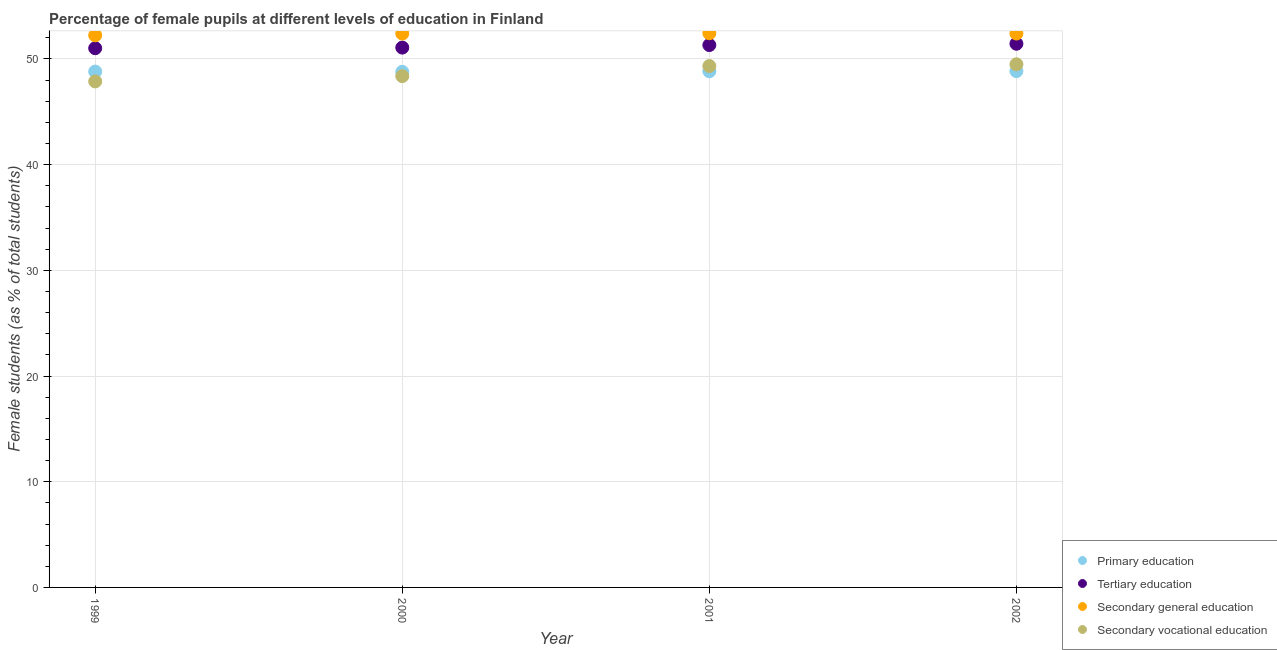What is the percentage of female students in primary education in 2001?
Offer a very short reply. 48.84. Across all years, what is the maximum percentage of female students in tertiary education?
Your answer should be compact. 51.44. Across all years, what is the minimum percentage of female students in secondary education?
Make the answer very short. 52.24. In which year was the percentage of female students in secondary education maximum?
Provide a short and direct response. 2001. In which year was the percentage of female students in secondary vocational education minimum?
Your response must be concise. 1999. What is the total percentage of female students in secondary vocational education in the graph?
Your response must be concise. 195.09. What is the difference between the percentage of female students in tertiary education in 1999 and that in 2002?
Keep it short and to the point. -0.42. What is the difference between the percentage of female students in primary education in 2002 and the percentage of female students in secondary vocational education in 2000?
Offer a terse response. 0.47. What is the average percentage of female students in tertiary education per year?
Ensure brevity in your answer.  51.21. In the year 2001, what is the difference between the percentage of female students in secondary education and percentage of female students in secondary vocational education?
Offer a terse response. 3.1. What is the ratio of the percentage of female students in secondary vocational education in 1999 to that in 2001?
Give a very brief answer. 0.97. Is the percentage of female students in secondary education in 1999 less than that in 2001?
Offer a very short reply. Yes. Is the difference between the percentage of female students in primary education in 1999 and 2000 greater than the difference between the percentage of female students in secondary vocational education in 1999 and 2000?
Keep it short and to the point. Yes. What is the difference between the highest and the second highest percentage of female students in secondary vocational education?
Keep it short and to the point. 0.17. What is the difference between the highest and the lowest percentage of female students in tertiary education?
Give a very brief answer. 0.42. In how many years, is the percentage of female students in primary education greater than the average percentage of female students in primary education taken over all years?
Give a very brief answer. 2. Is the percentage of female students in tertiary education strictly less than the percentage of female students in primary education over the years?
Make the answer very short. No. How many dotlines are there?
Ensure brevity in your answer.  4. How many years are there in the graph?
Your answer should be very brief. 4. What is the difference between two consecutive major ticks on the Y-axis?
Your answer should be compact. 10. Does the graph contain any zero values?
Give a very brief answer. No. Where does the legend appear in the graph?
Offer a very short reply. Bottom right. How many legend labels are there?
Offer a terse response. 4. What is the title of the graph?
Make the answer very short. Percentage of female pupils at different levels of education in Finland. Does "Taxes on exports" appear as one of the legend labels in the graph?
Offer a terse response. No. What is the label or title of the X-axis?
Your answer should be compact. Year. What is the label or title of the Y-axis?
Your response must be concise. Female students (as % of total students). What is the Female students (as % of total students) in Primary education in 1999?
Ensure brevity in your answer.  48.81. What is the Female students (as % of total students) of Tertiary education in 1999?
Your answer should be compact. 51.02. What is the Female students (as % of total students) in Secondary general education in 1999?
Your answer should be compact. 52.24. What is the Female students (as % of total students) in Secondary vocational education in 1999?
Your answer should be compact. 47.88. What is the Female students (as % of total students) in Primary education in 2000?
Your response must be concise. 48.78. What is the Female students (as % of total students) in Tertiary education in 2000?
Make the answer very short. 51.08. What is the Female students (as % of total students) in Secondary general education in 2000?
Your response must be concise. 52.41. What is the Female students (as % of total students) in Secondary vocational education in 2000?
Your answer should be very brief. 48.38. What is the Female students (as % of total students) of Primary education in 2001?
Your answer should be very brief. 48.84. What is the Female students (as % of total students) of Tertiary education in 2001?
Your response must be concise. 51.32. What is the Female students (as % of total students) of Secondary general education in 2001?
Your response must be concise. 52.44. What is the Female students (as % of total students) in Secondary vocational education in 2001?
Your response must be concise. 49.33. What is the Female students (as % of total students) in Primary education in 2002?
Ensure brevity in your answer.  48.85. What is the Female students (as % of total students) of Tertiary education in 2002?
Offer a very short reply. 51.44. What is the Female students (as % of total students) of Secondary general education in 2002?
Provide a short and direct response. 52.41. What is the Female students (as % of total students) of Secondary vocational education in 2002?
Make the answer very short. 49.5. Across all years, what is the maximum Female students (as % of total students) of Primary education?
Make the answer very short. 48.85. Across all years, what is the maximum Female students (as % of total students) of Tertiary education?
Your answer should be compact. 51.44. Across all years, what is the maximum Female students (as % of total students) in Secondary general education?
Provide a short and direct response. 52.44. Across all years, what is the maximum Female students (as % of total students) of Secondary vocational education?
Keep it short and to the point. 49.5. Across all years, what is the minimum Female students (as % of total students) in Primary education?
Ensure brevity in your answer.  48.78. Across all years, what is the minimum Female students (as % of total students) in Tertiary education?
Your answer should be very brief. 51.02. Across all years, what is the minimum Female students (as % of total students) in Secondary general education?
Provide a short and direct response. 52.24. Across all years, what is the minimum Female students (as % of total students) of Secondary vocational education?
Offer a very short reply. 47.88. What is the total Female students (as % of total students) of Primary education in the graph?
Offer a terse response. 195.28. What is the total Female students (as % of total students) of Tertiary education in the graph?
Offer a terse response. 204.85. What is the total Female students (as % of total students) of Secondary general education in the graph?
Make the answer very short. 209.49. What is the total Female students (as % of total students) in Secondary vocational education in the graph?
Provide a short and direct response. 195.09. What is the difference between the Female students (as % of total students) of Primary education in 1999 and that in 2000?
Make the answer very short. 0.03. What is the difference between the Female students (as % of total students) in Tertiary education in 1999 and that in 2000?
Offer a terse response. -0.06. What is the difference between the Female students (as % of total students) in Secondary general education in 1999 and that in 2000?
Provide a short and direct response. -0.17. What is the difference between the Female students (as % of total students) in Secondary vocational education in 1999 and that in 2000?
Provide a succinct answer. -0.5. What is the difference between the Female students (as % of total students) of Primary education in 1999 and that in 2001?
Provide a succinct answer. -0.04. What is the difference between the Female students (as % of total students) of Tertiary education in 1999 and that in 2001?
Your response must be concise. -0.3. What is the difference between the Female students (as % of total students) of Secondary general education in 1999 and that in 2001?
Your response must be concise. -0.2. What is the difference between the Female students (as % of total students) of Secondary vocational education in 1999 and that in 2001?
Provide a short and direct response. -1.46. What is the difference between the Female students (as % of total students) of Primary education in 1999 and that in 2002?
Offer a terse response. -0.04. What is the difference between the Female students (as % of total students) of Tertiary education in 1999 and that in 2002?
Your answer should be very brief. -0.42. What is the difference between the Female students (as % of total students) in Secondary general education in 1999 and that in 2002?
Your response must be concise. -0.17. What is the difference between the Female students (as % of total students) in Secondary vocational education in 1999 and that in 2002?
Your answer should be very brief. -1.62. What is the difference between the Female students (as % of total students) in Primary education in 2000 and that in 2001?
Your answer should be compact. -0.06. What is the difference between the Female students (as % of total students) in Tertiary education in 2000 and that in 2001?
Ensure brevity in your answer.  -0.24. What is the difference between the Female students (as % of total students) in Secondary general education in 2000 and that in 2001?
Your answer should be compact. -0.03. What is the difference between the Female students (as % of total students) in Secondary vocational education in 2000 and that in 2001?
Your response must be concise. -0.95. What is the difference between the Female students (as % of total students) of Primary education in 2000 and that in 2002?
Provide a succinct answer. -0.07. What is the difference between the Female students (as % of total students) in Tertiary education in 2000 and that in 2002?
Keep it short and to the point. -0.37. What is the difference between the Female students (as % of total students) in Secondary general education in 2000 and that in 2002?
Give a very brief answer. 0. What is the difference between the Female students (as % of total students) in Secondary vocational education in 2000 and that in 2002?
Your answer should be compact. -1.12. What is the difference between the Female students (as % of total students) in Primary education in 2001 and that in 2002?
Provide a succinct answer. -0.01. What is the difference between the Female students (as % of total students) in Tertiary education in 2001 and that in 2002?
Ensure brevity in your answer.  -0.13. What is the difference between the Female students (as % of total students) of Secondary general education in 2001 and that in 2002?
Your answer should be very brief. 0.03. What is the difference between the Female students (as % of total students) in Secondary vocational education in 2001 and that in 2002?
Your answer should be compact. -0.17. What is the difference between the Female students (as % of total students) of Primary education in 1999 and the Female students (as % of total students) of Tertiary education in 2000?
Provide a short and direct response. -2.27. What is the difference between the Female students (as % of total students) in Primary education in 1999 and the Female students (as % of total students) in Secondary general education in 2000?
Your answer should be very brief. -3.6. What is the difference between the Female students (as % of total students) in Primary education in 1999 and the Female students (as % of total students) in Secondary vocational education in 2000?
Provide a succinct answer. 0.43. What is the difference between the Female students (as % of total students) in Tertiary education in 1999 and the Female students (as % of total students) in Secondary general education in 2000?
Offer a very short reply. -1.39. What is the difference between the Female students (as % of total students) in Tertiary education in 1999 and the Female students (as % of total students) in Secondary vocational education in 2000?
Provide a succinct answer. 2.64. What is the difference between the Female students (as % of total students) of Secondary general education in 1999 and the Female students (as % of total students) of Secondary vocational education in 2000?
Keep it short and to the point. 3.86. What is the difference between the Female students (as % of total students) in Primary education in 1999 and the Female students (as % of total students) in Tertiary education in 2001?
Your response must be concise. -2.51. What is the difference between the Female students (as % of total students) in Primary education in 1999 and the Female students (as % of total students) in Secondary general education in 2001?
Provide a short and direct response. -3.63. What is the difference between the Female students (as % of total students) in Primary education in 1999 and the Female students (as % of total students) in Secondary vocational education in 2001?
Offer a terse response. -0.53. What is the difference between the Female students (as % of total students) of Tertiary education in 1999 and the Female students (as % of total students) of Secondary general education in 2001?
Your response must be concise. -1.42. What is the difference between the Female students (as % of total students) in Tertiary education in 1999 and the Female students (as % of total students) in Secondary vocational education in 2001?
Your answer should be very brief. 1.69. What is the difference between the Female students (as % of total students) in Secondary general education in 1999 and the Female students (as % of total students) in Secondary vocational education in 2001?
Your response must be concise. 2.91. What is the difference between the Female students (as % of total students) in Primary education in 1999 and the Female students (as % of total students) in Tertiary education in 2002?
Make the answer very short. -2.64. What is the difference between the Female students (as % of total students) in Primary education in 1999 and the Female students (as % of total students) in Secondary general education in 2002?
Your answer should be very brief. -3.6. What is the difference between the Female students (as % of total students) in Primary education in 1999 and the Female students (as % of total students) in Secondary vocational education in 2002?
Your answer should be compact. -0.69. What is the difference between the Female students (as % of total students) of Tertiary education in 1999 and the Female students (as % of total students) of Secondary general education in 2002?
Your response must be concise. -1.39. What is the difference between the Female students (as % of total students) in Tertiary education in 1999 and the Female students (as % of total students) in Secondary vocational education in 2002?
Offer a very short reply. 1.52. What is the difference between the Female students (as % of total students) in Secondary general education in 1999 and the Female students (as % of total students) in Secondary vocational education in 2002?
Offer a terse response. 2.74. What is the difference between the Female students (as % of total students) of Primary education in 2000 and the Female students (as % of total students) of Tertiary education in 2001?
Keep it short and to the point. -2.53. What is the difference between the Female students (as % of total students) in Primary education in 2000 and the Female students (as % of total students) in Secondary general education in 2001?
Your response must be concise. -3.65. What is the difference between the Female students (as % of total students) in Primary education in 2000 and the Female students (as % of total students) in Secondary vocational education in 2001?
Provide a succinct answer. -0.55. What is the difference between the Female students (as % of total students) in Tertiary education in 2000 and the Female students (as % of total students) in Secondary general education in 2001?
Your answer should be compact. -1.36. What is the difference between the Female students (as % of total students) of Tertiary education in 2000 and the Female students (as % of total students) of Secondary vocational education in 2001?
Keep it short and to the point. 1.74. What is the difference between the Female students (as % of total students) in Secondary general education in 2000 and the Female students (as % of total students) in Secondary vocational education in 2001?
Your answer should be compact. 3.07. What is the difference between the Female students (as % of total students) in Primary education in 2000 and the Female students (as % of total students) in Tertiary education in 2002?
Keep it short and to the point. -2.66. What is the difference between the Female students (as % of total students) in Primary education in 2000 and the Female students (as % of total students) in Secondary general education in 2002?
Your answer should be very brief. -3.62. What is the difference between the Female students (as % of total students) in Primary education in 2000 and the Female students (as % of total students) in Secondary vocational education in 2002?
Provide a succinct answer. -0.72. What is the difference between the Female students (as % of total students) in Tertiary education in 2000 and the Female students (as % of total students) in Secondary general education in 2002?
Your answer should be very brief. -1.33. What is the difference between the Female students (as % of total students) of Tertiary education in 2000 and the Female students (as % of total students) of Secondary vocational education in 2002?
Your answer should be compact. 1.58. What is the difference between the Female students (as % of total students) of Secondary general education in 2000 and the Female students (as % of total students) of Secondary vocational education in 2002?
Offer a very short reply. 2.91. What is the difference between the Female students (as % of total students) of Primary education in 2001 and the Female students (as % of total students) of Tertiary education in 2002?
Your answer should be very brief. -2.6. What is the difference between the Female students (as % of total students) of Primary education in 2001 and the Female students (as % of total students) of Secondary general education in 2002?
Make the answer very short. -3.56. What is the difference between the Female students (as % of total students) in Primary education in 2001 and the Female students (as % of total students) in Secondary vocational education in 2002?
Give a very brief answer. -0.65. What is the difference between the Female students (as % of total students) in Tertiary education in 2001 and the Female students (as % of total students) in Secondary general education in 2002?
Offer a very short reply. -1.09. What is the difference between the Female students (as % of total students) of Tertiary education in 2001 and the Female students (as % of total students) of Secondary vocational education in 2002?
Provide a short and direct response. 1.82. What is the difference between the Female students (as % of total students) in Secondary general education in 2001 and the Female students (as % of total students) in Secondary vocational education in 2002?
Offer a very short reply. 2.94. What is the average Female students (as % of total students) of Primary education per year?
Your answer should be compact. 48.82. What is the average Female students (as % of total students) of Tertiary education per year?
Ensure brevity in your answer.  51.21. What is the average Female students (as % of total students) in Secondary general education per year?
Provide a short and direct response. 52.37. What is the average Female students (as % of total students) of Secondary vocational education per year?
Give a very brief answer. 48.77. In the year 1999, what is the difference between the Female students (as % of total students) in Primary education and Female students (as % of total students) in Tertiary education?
Your response must be concise. -2.21. In the year 1999, what is the difference between the Female students (as % of total students) of Primary education and Female students (as % of total students) of Secondary general education?
Keep it short and to the point. -3.43. In the year 1999, what is the difference between the Female students (as % of total students) of Primary education and Female students (as % of total students) of Secondary vocational education?
Your answer should be very brief. 0.93. In the year 1999, what is the difference between the Female students (as % of total students) of Tertiary education and Female students (as % of total students) of Secondary general education?
Offer a terse response. -1.22. In the year 1999, what is the difference between the Female students (as % of total students) of Tertiary education and Female students (as % of total students) of Secondary vocational education?
Give a very brief answer. 3.14. In the year 1999, what is the difference between the Female students (as % of total students) of Secondary general education and Female students (as % of total students) of Secondary vocational education?
Ensure brevity in your answer.  4.36. In the year 2000, what is the difference between the Female students (as % of total students) in Primary education and Female students (as % of total students) in Tertiary education?
Ensure brevity in your answer.  -2.3. In the year 2000, what is the difference between the Female students (as % of total students) of Primary education and Female students (as % of total students) of Secondary general education?
Ensure brevity in your answer.  -3.62. In the year 2000, what is the difference between the Female students (as % of total students) in Primary education and Female students (as % of total students) in Secondary vocational education?
Provide a succinct answer. 0.4. In the year 2000, what is the difference between the Female students (as % of total students) of Tertiary education and Female students (as % of total students) of Secondary general education?
Your answer should be compact. -1.33. In the year 2000, what is the difference between the Female students (as % of total students) in Tertiary education and Female students (as % of total students) in Secondary vocational education?
Offer a very short reply. 2.7. In the year 2000, what is the difference between the Female students (as % of total students) of Secondary general education and Female students (as % of total students) of Secondary vocational education?
Your response must be concise. 4.03. In the year 2001, what is the difference between the Female students (as % of total students) of Primary education and Female students (as % of total students) of Tertiary education?
Keep it short and to the point. -2.47. In the year 2001, what is the difference between the Female students (as % of total students) of Primary education and Female students (as % of total students) of Secondary general education?
Your answer should be very brief. -3.59. In the year 2001, what is the difference between the Female students (as % of total students) in Primary education and Female students (as % of total students) in Secondary vocational education?
Make the answer very short. -0.49. In the year 2001, what is the difference between the Female students (as % of total students) in Tertiary education and Female students (as % of total students) in Secondary general education?
Offer a terse response. -1.12. In the year 2001, what is the difference between the Female students (as % of total students) in Tertiary education and Female students (as % of total students) in Secondary vocational education?
Your response must be concise. 1.98. In the year 2001, what is the difference between the Female students (as % of total students) of Secondary general education and Female students (as % of total students) of Secondary vocational education?
Ensure brevity in your answer.  3.1. In the year 2002, what is the difference between the Female students (as % of total students) in Primary education and Female students (as % of total students) in Tertiary education?
Keep it short and to the point. -2.59. In the year 2002, what is the difference between the Female students (as % of total students) of Primary education and Female students (as % of total students) of Secondary general education?
Make the answer very short. -3.55. In the year 2002, what is the difference between the Female students (as % of total students) in Primary education and Female students (as % of total students) in Secondary vocational education?
Provide a short and direct response. -0.65. In the year 2002, what is the difference between the Female students (as % of total students) of Tertiary education and Female students (as % of total students) of Secondary general education?
Provide a succinct answer. -0.96. In the year 2002, what is the difference between the Female students (as % of total students) of Tertiary education and Female students (as % of total students) of Secondary vocational education?
Provide a short and direct response. 1.94. In the year 2002, what is the difference between the Female students (as % of total students) of Secondary general education and Female students (as % of total students) of Secondary vocational education?
Give a very brief answer. 2.91. What is the ratio of the Female students (as % of total students) in Primary education in 1999 to that in 2000?
Provide a short and direct response. 1. What is the ratio of the Female students (as % of total students) in Tertiary education in 1999 to that in 2000?
Your answer should be very brief. 1. What is the ratio of the Female students (as % of total students) in Secondary general education in 1999 to that in 2000?
Provide a short and direct response. 1. What is the ratio of the Female students (as % of total students) of Primary education in 1999 to that in 2001?
Your answer should be compact. 1. What is the ratio of the Female students (as % of total students) of Secondary general education in 1999 to that in 2001?
Keep it short and to the point. 1. What is the ratio of the Female students (as % of total students) of Secondary vocational education in 1999 to that in 2001?
Offer a terse response. 0.97. What is the ratio of the Female students (as % of total students) in Tertiary education in 1999 to that in 2002?
Provide a succinct answer. 0.99. What is the ratio of the Female students (as % of total students) in Secondary vocational education in 1999 to that in 2002?
Your response must be concise. 0.97. What is the ratio of the Female students (as % of total students) of Tertiary education in 2000 to that in 2001?
Offer a very short reply. 1. What is the ratio of the Female students (as % of total students) in Secondary vocational education in 2000 to that in 2001?
Offer a very short reply. 0.98. What is the ratio of the Female students (as % of total students) in Tertiary education in 2000 to that in 2002?
Offer a very short reply. 0.99. What is the ratio of the Female students (as % of total students) of Secondary vocational education in 2000 to that in 2002?
Offer a very short reply. 0.98. What is the ratio of the Female students (as % of total students) of Tertiary education in 2001 to that in 2002?
Your answer should be compact. 1. What is the ratio of the Female students (as % of total students) of Secondary general education in 2001 to that in 2002?
Ensure brevity in your answer.  1. What is the difference between the highest and the second highest Female students (as % of total students) of Primary education?
Provide a succinct answer. 0.01. What is the difference between the highest and the second highest Female students (as % of total students) in Tertiary education?
Make the answer very short. 0.13. What is the difference between the highest and the second highest Female students (as % of total students) of Secondary general education?
Give a very brief answer. 0.03. What is the difference between the highest and the second highest Female students (as % of total students) of Secondary vocational education?
Keep it short and to the point. 0.17. What is the difference between the highest and the lowest Female students (as % of total students) in Primary education?
Provide a short and direct response. 0.07. What is the difference between the highest and the lowest Female students (as % of total students) in Tertiary education?
Ensure brevity in your answer.  0.42. What is the difference between the highest and the lowest Female students (as % of total students) of Secondary general education?
Your answer should be very brief. 0.2. What is the difference between the highest and the lowest Female students (as % of total students) in Secondary vocational education?
Offer a terse response. 1.62. 